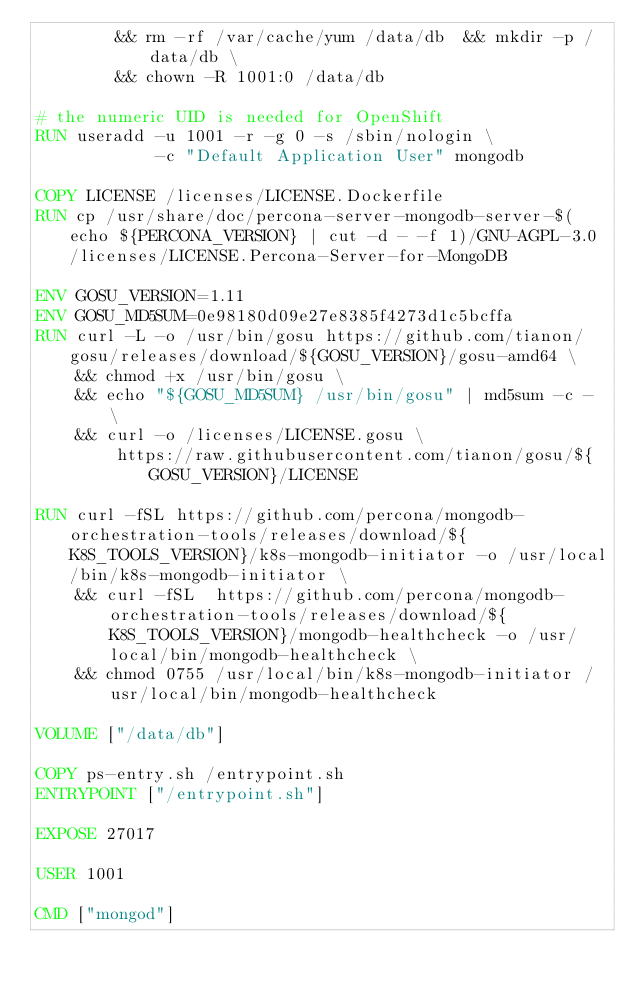<code> <loc_0><loc_0><loc_500><loc_500><_Dockerfile_>		&& rm -rf /var/cache/yum /data/db  && mkdir -p /data/db \
		&& chown -R 1001:0 /data/db

# the numeric UID is needed for OpenShift
RUN useradd -u 1001 -r -g 0 -s /sbin/nologin \
            -c "Default Application User" mongodb

COPY LICENSE /licenses/LICENSE.Dockerfile
RUN cp /usr/share/doc/percona-server-mongodb-server-$(echo ${PERCONA_VERSION} | cut -d - -f 1)/GNU-AGPL-3.0 /licenses/LICENSE.Percona-Server-for-MongoDB

ENV GOSU_VERSION=1.11
ENV GOSU_MD5SUM=0e98180d09e27e8385f4273d1c5bcffa
RUN curl -L -o /usr/bin/gosu https://github.com/tianon/gosu/releases/download/${GOSU_VERSION}/gosu-amd64 \
	&& chmod +x /usr/bin/gosu \
    && echo "${GOSU_MD5SUM} /usr/bin/gosu" | md5sum -c - \
    && curl -o /licenses/LICENSE.gosu \
		https://raw.githubusercontent.com/tianon/gosu/${GOSU_VERSION}/LICENSE

RUN curl -fSL https://github.com/percona/mongodb-orchestration-tools/releases/download/${K8S_TOOLS_VERSION}/k8s-mongodb-initiator -o /usr/local/bin/k8s-mongodb-initiator \
    && curl -fSL  https://github.com/percona/mongodb-orchestration-tools/releases/download/${K8S_TOOLS_VERSION}/mongodb-healthcheck -o /usr/local/bin/mongodb-healthcheck \
    && chmod 0755 /usr/local/bin/k8s-mongodb-initiator /usr/local/bin/mongodb-healthcheck

VOLUME ["/data/db"]

COPY ps-entry.sh /entrypoint.sh
ENTRYPOINT ["/entrypoint.sh"]

EXPOSE 27017

USER 1001

CMD ["mongod"]
</code> 